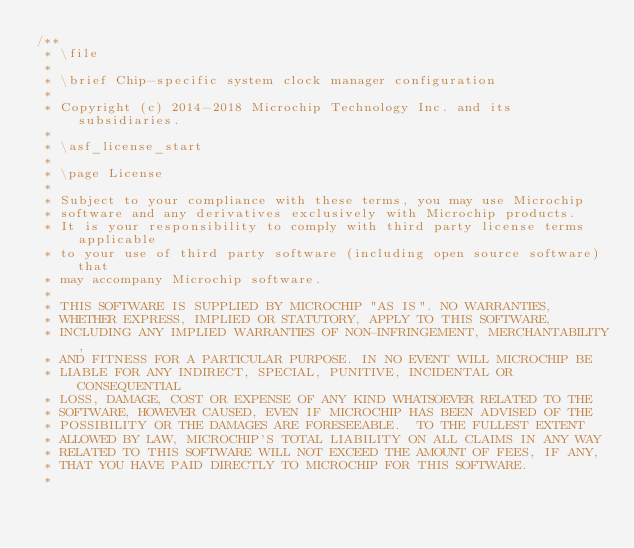<code> <loc_0><loc_0><loc_500><loc_500><_C_>/**
 * \file
 *
 * \brief Chip-specific system clock manager configuration
 *
 * Copyright (c) 2014-2018 Microchip Technology Inc. and its subsidiaries.
 *
 * \asf_license_start
 *
 * \page License
 *
 * Subject to your compliance with these terms, you may use Microchip
 * software and any derivatives exclusively with Microchip products.
 * It is your responsibility to comply with third party license terms applicable
 * to your use of third party software (including open source software) that
 * may accompany Microchip software.
 *
 * THIS SOFTWARE IS SUPPLIED BY MICROCHIP "AS IS". NO WARRANTIES,
 * WHETHER EXPRESS, IMPLIED OR STATUTORY, APPLY TO THIS SOFTWARE,
 * INCLUDING ANY IMPLIED WARRANTIES OF NON-INFRINGEMENT, MERCHANTABILITY,
 * AND FITNESS FOR A PARTICULAR PURPOSE. IN NO EVENT WILL MICROCHIP BE
 * LIABLE FOR ANY INDIRECT, SPECIAL, PUNITIVE, INCIDENTAL OR CONSEQUENTIAL
 * LOSS, DAMAGE, COST OR EXPENSE OF ANY KIND WHATSOEVER RELATED TO THE
 * SOFTWARE, HOWEVER CAUSED, EVEN IF MICROCHIP HAS BEEN ADVISED OF THE
 * POSSIBILITY OR THE DAMAGES ARE FORESEEABLE.  TO THE FULLEST EXTENT
 * ALLOWED BY LAW, MICROCHIP'S TOTAL LIABILITY ON ALL CLAIMS IN ANY WAY
 * RELATED TO THIS SOFTWARE WILL NOT EXCEED THE AMOUNT OF FEES, IF ANY,
 * THAT YOU HAVE PAID DIRECTLY TO MICROCHIP FOR THIS SOFTWARE.
 *</code> 